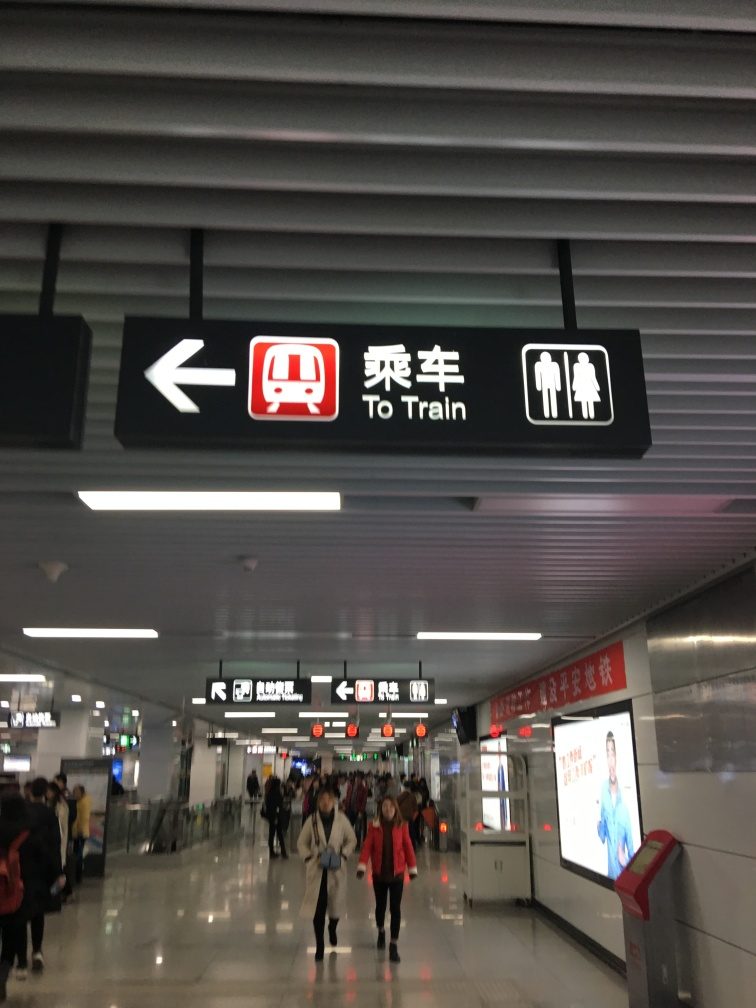Is the focus clear enough? The focus appears reasonably clear. The signage and elements in the foreground are in focus, while the background, including the people and the environment, shows a slight decrease in sharpness typical for photographs with a deeper depth of field. The sign indicating 'To Train' along with symbols for restrooms is easily legible, suggesting that the overall clarity of the image is adequate for understanding the scene. 